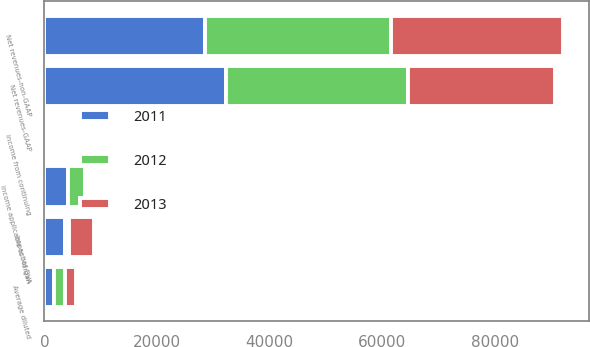<chart> <loc_0><loc_0><loc_500><loc_500><stacked_bar_chart><ecel><fcel>Net revenues-non-GAAP<fcel>Impact of DVA<fcel>Net revenues-GAAP<fcel>Income applicable to Morgan<fcel>Income from continuing<fcel>Average diluted<nl><fcel>2012<fcel>33098<fcel>681<fcel>32417<fcel>2975<fcel>1.38<fcel>1957<nl><fcel>2013<fcel>30504<fcel>4402<fcel>26102<fcel>138<fcel>0.02<fcel>1919<nl><fcel>2011<fcel>28546<fcel>3681<fcel>32227<fcel>4168<fcel>1.27<fcel>1655<nl></chart> 